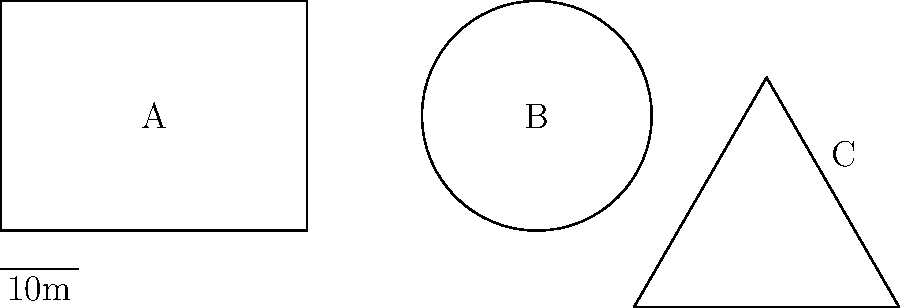As an event coordinator, you're considering three differently shaped venues for an upcoming music festival. The overhead views of these venues are shown above, labeled A, B, and C. Given that each square meter can safely accommodate 4 people, which venue has the highest crowd capacity? Assume that the entire area of each venue can be used. To determine which venue has the highest crowd capacity, we need to calculate the area of each venue and multiply it by the crowd density (4 people per square meter).

1. Venue A (Rectangle):
   Length = 8 units, Width = 6 units
   Area = $8 \times 6 = 48$ square units
   Each unit represents 5 meters (10m / 2 units from scale)
   Actual area = $48 \times 5^2 = 1200$ sq meters
   Capacity = $1200 \times 4 = 4800$ people

2. Venue B (Circle):
   Radius = 3 units = 15 meters
   Area = $\pi r^2 = \pi \times 15^2 \approx 706.86$ sq meters
   Capacity = $706.86 \times 4 \approx 2827$ people

3. Venue C (Equilateral Triangle):
   Side length = 4 units = 20 meters
   Area = $\frac{\sqrt{3}}{4} \times 20^2 \approx 173.21$ sq meters
   Capacity = $173.21 \times 4 \approx 693$ people

Venue A (Rectangle) has the highest capacity at 4800 people.
Answer: Venue A (Rectangle) 